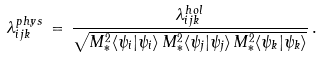Convert formula to latex. <formula><loc_0><loc_0><loc_500><loc_500>\lambda ^ { p h y s } _ { i j k } \, = \, \frac { \lambda ^ { h o l } _ { i j k } } { \sqrt { M _ { * } ^ { 2 } \langle \psi _ { i } | \psi _ { i } \rangle \, M _ { * } ^ { 2 } \langle \psi _ { j } | \psi _ { j } \rangle \, M _ { * } ^ { 2 } \langle \psi _ { k } | \psi _ { k } \rangle } } \, .</formula> 